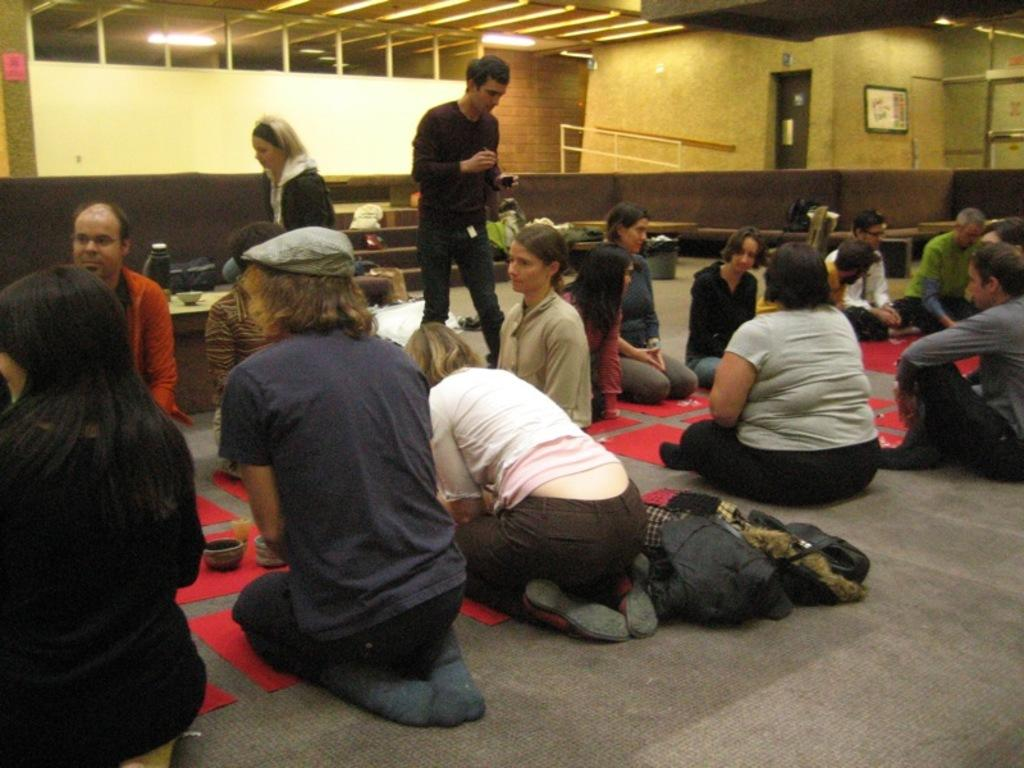How many people are in the image? There is a group of girls and a boy in the image, making a total of four people. What are they sitting on? They are sitting on a mat. What can be seen behind them? There is a yellow and brown color wall in the background. What is visible above them? The ceiling with lights is visible above. What shape is the pail that the boy is holding in the image? There is no pail present in the image, so it is not possible to determine its shape. 